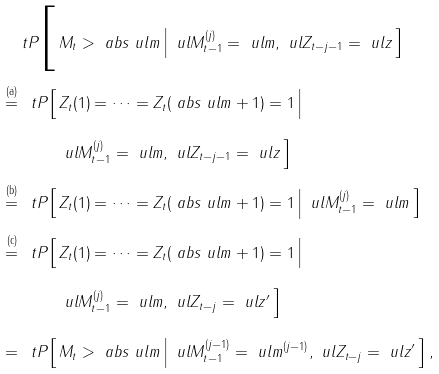Convert formula to latex. <formula><loc_0><loc_0><loc_500><loc_500>\ t P \Big [ \, & M _ { t } > \ a b s { \ u l { m } } \, \Big | \, \ u l { M } _ { t - 1 } ^ { ( j ) } = \ u l { m } , \ u l { Z } _ { t - j - 1 } = \ u l { z } \, \Big ] \\ \overset { \text {(a)} } { = } \, \ t P \Big [ \, & Z _ { t } ( 1 ) = \dots = Z _ { t } ( \ a b s { \ u l { m } } + 1 ) = 1 \, \Big | \, \\ & \ u l { M } _ { t - 1 } ^ { ( j ) } = \ u l { m } , \ u l { Z } _ { t - j - 1 } = \ u l { z } \, \Big ] \\ \overset { \text {(b)} } { = } \, \ t P \Big [ \, & Z _ { t } ( 1 ) = \dots = Z _ { t } ( \ a b s { \ u l { m } } + 1 ) = 1 \, \Big | \, \ u l { M } _ { t - 1 } ^ { ( j ) } = \ u l { m } \, \Big ] \\ \overset { \text {(c)} } { = } \, \ t P \Big [ \, & Z _ { t } ( 1 ) = \dots = Z _ { t } ( \ a b s { \ u l { m } } + 1 ) = 1 \, \Big | \, \\ & \ u l { M } _ { t - 1 } ^ { ( j ) } = \ u l { m } , \ u l { Z } _ { t - j } = \ u l { z } ^ { \prime } \, \Big ] \\ = \, \ t P \Big [ \, & M _ { t } > \ a b s { \ u l { m } } \, \Big | \, \ u l { M } _ { t - 1 } ^ { ( j - 1 ) } = \ u l { m } ^ { ( j - 1 ) } , \ u l { Z } _ { t - j } = \ u l { z } ^ { \prime } \, \Big ] \, ,</formula> 